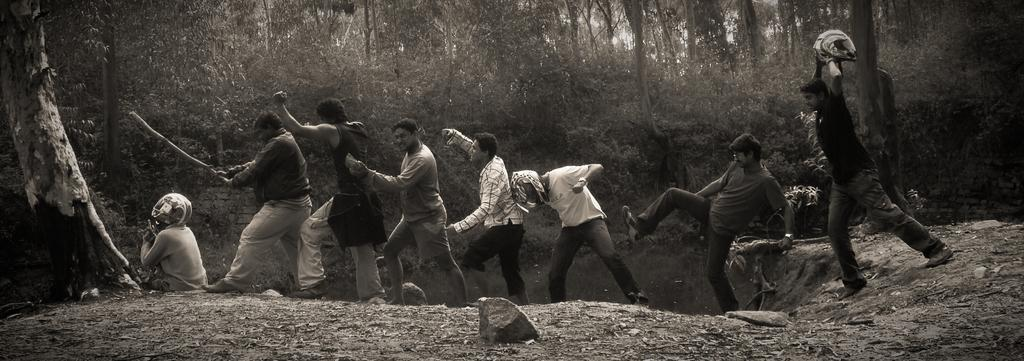What is present at the bottom of the image? There is mud at the bottom of the image. What can be seen in the foreground of the image? There are people in the foreground of the image. What type of vegetation is visible in the background of the image? There are trees in the background of the image. Where are the trees and bark located in the image? They are in the left corner of the image. What type of owl can be seen perched on the tree in the image? There is no owl present in the image; it only features people, mud, and trees. What bone is visible in the image? There is no bone visible in the image. 